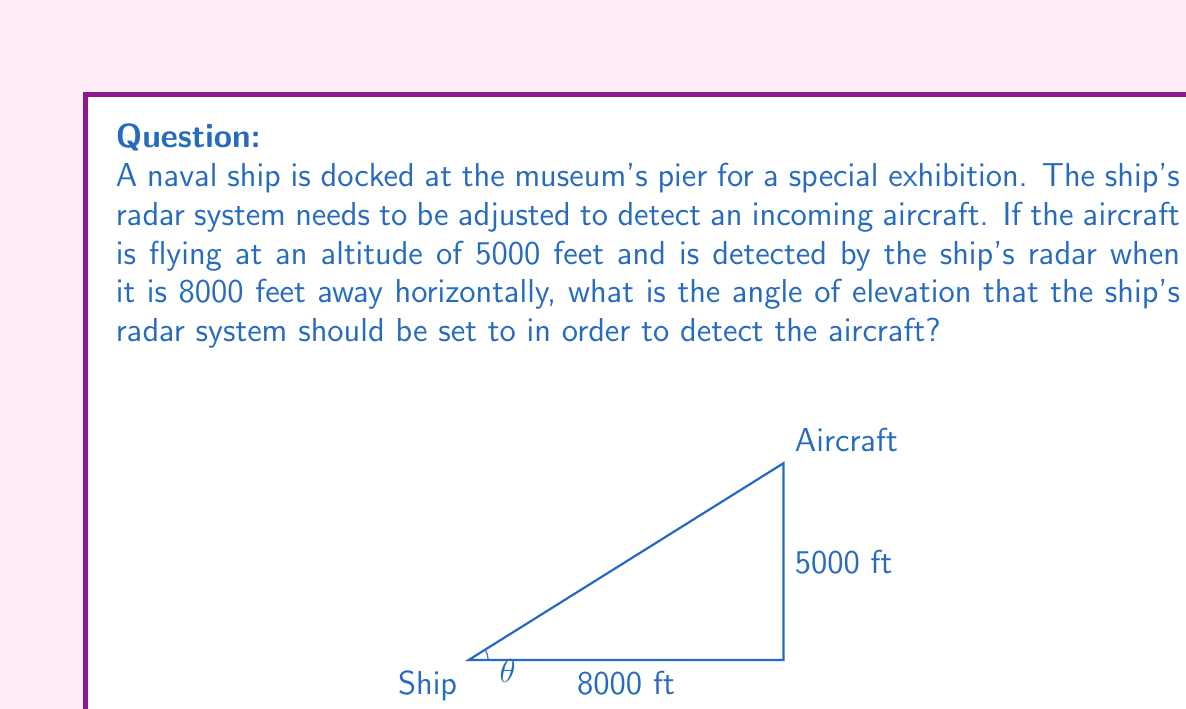What is the answer to this math problem? To solve this problem, we need to use trigonometry, specifically the tangent function. Let's break it down step-by-step:

1) We can consider this scenario as a right triangle, where:
   - The base of the triangle is the horizontal distance (8000 feet)
   - The height of the triangle is the aircraft's altitude (5000 feet)
   - The angle we're looking for is the angle of elevation at the ship

2) In a right triangle, tangent of an angle is the ratio of the opposite side to the adjacent side.

3) Let $\theta$ be the angle of elevation. Then:

   $$\tan(\theta) = \frac{\text{opposite}}{\text{adjacent}} = \frac{\text{altitude}}{\text{horizontal distance}}$$

4) Substituting our values:

   $$\tan(\theta) = \frac{5000}{8000} = \frac{5}{8} = 0.625$$

5) To find $\theta$, we need to use the inverse tangent function (also known as arctangent or $\tan^{-1}$):

   $$\theta = \tan^{-1}(0.625)$$

6) Using a calculator or trigonometric tables:

   $$\theta \approx 32.0053°$$

7) Rounding to the nearest tenth of a degree:

   $$\theta \approx 32.0°$$

Therefore, the ship's radar system should be set to an angle of elevation of approximately 32.0°.
Answer: The angle of elevation for the ship's radar system should be set to approximately 32.0°. 